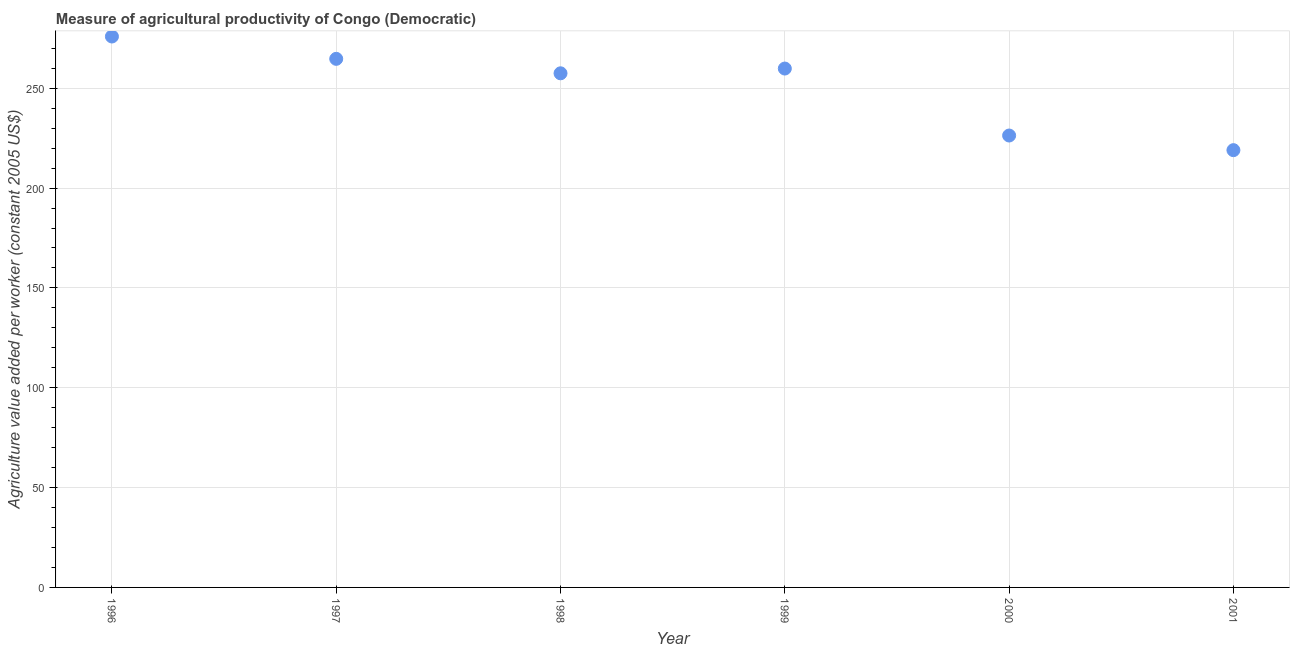What is the agriculture value added per worker in 2001?
Your answer should be very brief. 219.01. Across all years, what is the maximum agriculture value added per worker?
Make the answer very short. 275.92. Across all years, what is the minimum agriculture value added per worker?
Your answer should be very brief. 219.01. What is the sum of the agriculture value added per worker?
Your response must be concise. 1503.37. What is the difference between the agriculture value added per worker in 1996 and 2000?
Ensure brevity in your answer.  49.59. What is the average agriculture value added per worker per year?
Ensure brevity in your answer.  250.56. What is the median agriculture value added per worker?
Your answer should be very brief. 258.68. In how many years, is the agriculture value added per worker greater than 120 US$?
Offer a terse response. 6. Do a majority of the years between 2001 and 1998 (inclusive) have agriculture value added per worker greater than 230 US$?
Provide a succinct answer. Yes. What is the ratio of the agriculture value added per worker in 1996 to that in 1997?
Make the answer very short. 1.04. What is the difference between the highest and the second highest agriculture value added per worker?
Give a very brief answer. 11.19. Is the sum of the agriculture value added per worker in 2000 and 2001 greater than the maximum agriculture value added per worker across all years?
Offer a very short reply. Yes. What is the difference between the highest and the lowest agriculture value added per worker?
Your answer should be compact. 56.92. In how many years, is the agriculture value added per worker greater than the average agriculture value added per worker taken over all years?
Make the answer very short. 4. Does the agriculture value added per worker monotonically increase over the years?
Your answer should be compact. No. Are the values on the major ticks of Y-axis written in scientific E-notation?
Offer a terse response. No. Does the graph contain grids?
Offer a very short reply. Yes. What is the title of the graph?
Give a very brief answer. Measure of agricultural productivity of Congo (Democratic). What is the label or title of the X-axis?
Your response must be concise. Year. What is the label or title of the Y-axis?
Provide a succinct answer. Agriculture value added per worker (constant 2005 US$). What is the Agriculture value added per worker (constant 2005 US$) in 1996?
Keep it short and to the point. 275.92. What is the Agriculture value added per worker (constant 2005 US$) in 1997?
Your answer should be compact. 264.74. What is the Agriculture value added per worker (constant 2005 US$) in 1998?
Make the answer very short. 257.49. What is the Agriculture value added per worker (constant 2005 US$) in 1999?
Offer a terse response. 259.88. What is the Agriculture value added per worker (constant 2005 US$) in 2000?
Keep it short and to the point. 226.33. What is the Agriculture value added per worker (constant 2005 US$) in 2001?
Give a very brief answer. 219.01. What is the difference between the Agriculture value added per worker (constant 2005 US$) in 1996 and 1997?
Your answer should be very brief. 11.19. What is the difference between the Agriculture value added per worker (constant 2005 US$) in 1996 and 1998?
Provide a succinct answer. 18.43. What is the difference between the Agriculture value added per worker (constant 2005 US$) in 1996 and 1999?
Give a very brief answer. 16.05. What is the difference between the Agriculture value added per worker (constant 2005 US$) in 1996 and 2000?
Provide a short and direct response. 49.59. What is the difference between the Agriculture value added per worker (constant 2005 US$) in 1996 and 2001?
Keep it short and to the point. 56.92. What is the difference between the Agriculture value added per worker (constant 2005 US$) in 1997 and 1998?
Give a very brief answer. 7.24. What is the difference between the Agriculture value added per worker (constant 2005 US$) in 1997 and 1999?
Your response must be concise. 4.86. What is the difference between the Agriculture value added per worker (constant 2005 US$) in 1997 and 2000?
Make the answer very short. 38.41. What is the difference between the Agriculture value added per worker (constant 2005 US$) in 1997 and 2001?
Keep it short and to the point. 45.73. What is the difference between the Agriculture value added per worker (constant 2005 US$) in 1998 and 1999?
Provide a short and direct response. -2.38. What is the difference between the Agriculture value added per worker (constant 2005 US$) in 1998 and 2000?
Provide a short and direct response. 31.16. What is the difference between the Agriculture value added per worker (constant 2005 US$) in 1998 and 2001?
Your answer should be very brief. 38.49. What is the difference between the Agriculture value added per worker (constant 2005 US$) in 1999 and 2000?
Make the answer very short. 33.54. What is the difference between the Agriculture value added per worker (constant 2005 US$) in 1999 and 2001?
Your answer should be very brief. 40.87. What is the difference between the Agriculture value added per worker (constant 2005 US$) in 2000 and 2001?
Provide a succinct answer. 7.32. What is the ratio of the Agriculture value added per worker (constant 2005 US$) in 1996 to that in 1997?
Keep it short and to the point. 1.04. What is the ratio of the Agriculture value added per worker (constant 2005 US$) in 1996 to that in 1998?
Ensure brevity in your answer.  1.07. What is the ratio of the Agriculture value added per worker (constant 2005 US$) in 1996 to that in 1999?
Your answer should be compact. 1.06. What is the ratio of the Agriculture value added per worker (constant 2005 US$) in 1996 to that in 2000?
Offer a terse response. 1.22. What is the ratio of the Agriculture value added per worker (constant 2005 US$) in 1996 to that in 2001?
Provide a succinct answer. 1.26. What is the ratio of the Agriculture value added per worker (constant 2005 US$) in 1997 to that in 1998?
Ensure brevity in your answer.  1.03. What is the ratio of the Agriculture value added per worker (constant 2005 US$) in 1997 to that in 1999?
Your answer should be very brief. 1.02. What is the ratio of the Agriculture value added per worker (constant 2005 US$) in 1997 to that in 2000?
Keep it short and to the point. 1.17. What is the ratio of the Agriculture value added per worker (constant 2005 US$) in 1997 to that in 2001?
Your answer should be very brief. 1.21. What is the ratio of the Agriculture value added per worker (constant 2005 US$) in 1998 to that in 2000?
Make the answer very short. 1.14. What is the ratio of the Agriculture value added per worker (constant 2005 US$) in 1998 to that in 2001?
Give a very brief answer. 1.18. What is the ratio of the Agriculture value added per worker (constant 2005 US$) in 1999 to that in 2000?
Ensure brevity in your answer.  1.15. What is the ratio of the Agriculture value added per worker (constant 2005 US$) in 1999 to that in 2001?
Offer a very short reply. 1.19. What is the ratio of the Agriculture value added per worker (constant 2005 US$) in 2000 to that in 2001?
Give a very brief answer. 1.03. 